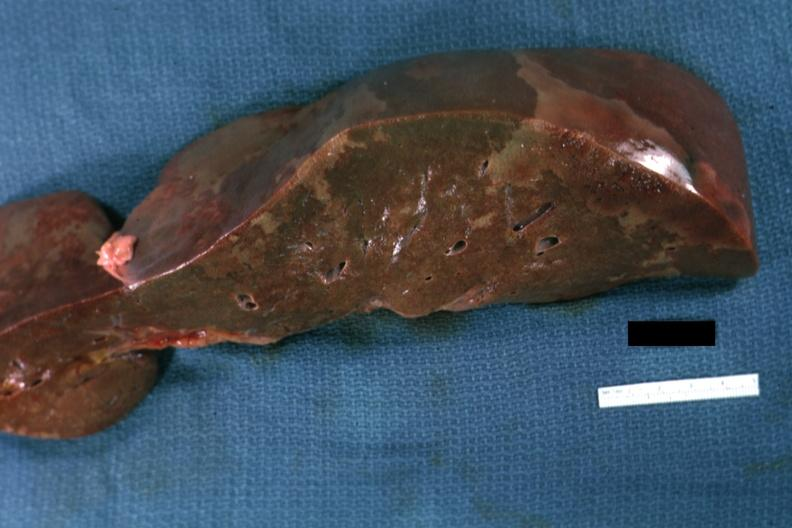what does this image show?
Answer the question using a single word or phrase. Large areas of infarction without appearance of severe congestion liver which is brownish color perhaps reflecting fatty change with severe shock history not available 